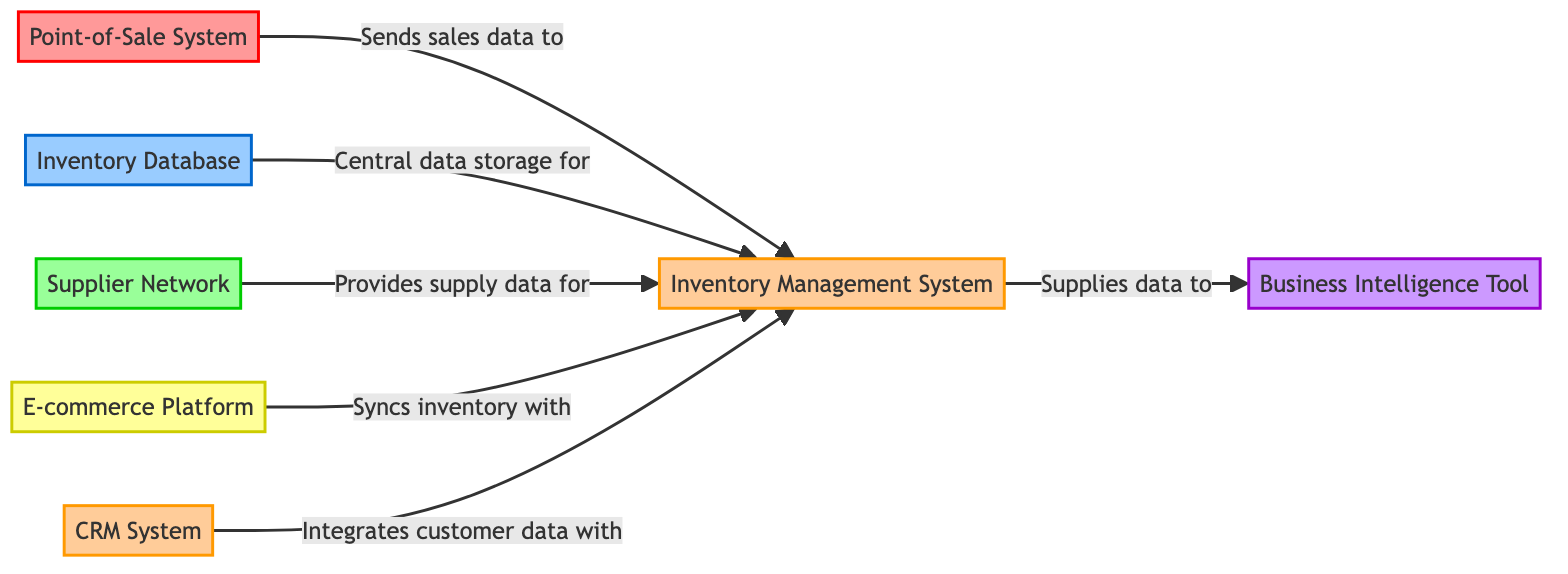What is the type of the node labeled "Point-of-Sale System"? The node labeled "Point-of-Sale System" is categorized as a "POS" type according to the diagram.
Answer: POS How many nodes are there in the diagram? By counting the distinct systems or components depicted in the diagram, there are a total of seven nodes representing different systems involved in the inventory management integration.
Answer: 7 What does the "Inventory Management System" supply data to? According to the diagram, the "Inventory Management System" supplies data to the "Business Intelligence Tool" as indicated by the directed edge connecting these two nodes.
Answer: Business Intelligence Tool Which node provides supply data for the "Inventory Management System"? The "Supplier Network" is the node that provides supply data for the "Inventory Management System," as shown by the connection between these two nodes in the diagram.
Answer: Supplier Network What is the relationship between the "E-commerce Platform" and the "Inventory Management System"? The relationship is that the "E-commerce Platform" syncs inventory with the "Inventory Management System," which is clearly indicated through the directed edge connecting these two components.
Answer: Syncs inventory with What type of system is the "CRM System"? The "CRM System" is classified as a "System" type, as stated in its details within the diagram and indicated by the corresponding styling of the node.
Answer: System How many edges connect to the "Inventory Management System"? The "Inventory Management System" has five edges connecting to it, representing relationships with different nodes that feed data into or interact with it.
Answer: 5 What is the main function of the "Business Intelligence Tool"? The primary function of the "Business Intelligence Tool" is to aggregate and analyze data from the "Inventory Management System," as detailed in the information for this node.
Answer: Aggregate and analyze data Which node integrates customer data with the "Inventory Management System"? The "CRM System" integrates customer data with the "Inventory Management System," as outlined in the directed edge that indicates this relationship.
Answer: CRM System 